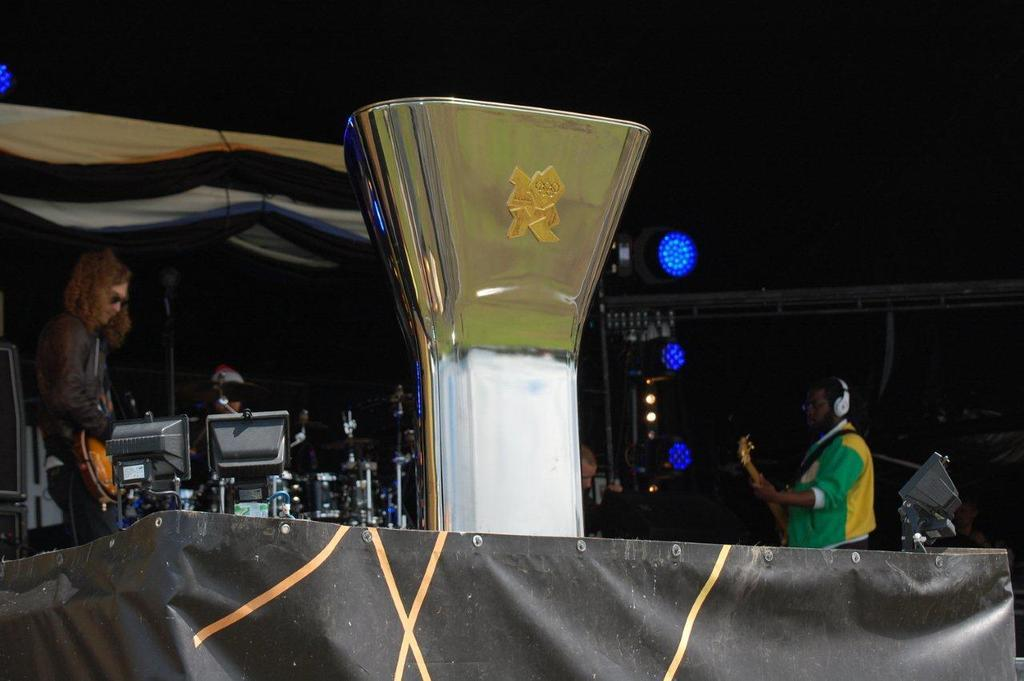What is the main subject in the center of the image? There is an object in the center of the image. What are the three people doing in the image? They are playing musical instruments. Is there any shelter provided in the image? Yes, there is a roof for shelter. What can be seen in the image that helps with visibility? Lights are present in the image. What is used for amplifying sound in the image? Microphones (mike's) are also present in the image. Can you tell me how many wings are visible in the image? There are no wings present in the image. What type of throat condition can be seen in the image? There is no indication of any throat condition in the image. 